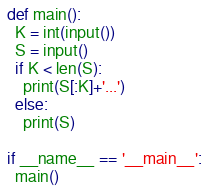<code> <loc_0><loc_0><loc_500><loc_500><_Python_>def main():
  K = int(input())
  S = input()
  if K < len(S):
    print(S[:K]+'...')
  else:
    print(S)    

if __name__ == '__main__':
  main()
</code> 